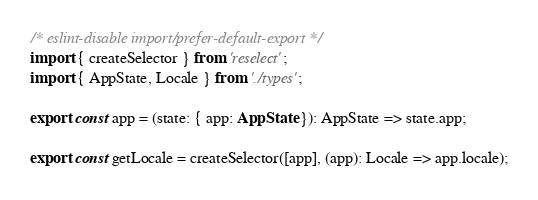<code> <loc_0><loc_0><loc_500><loc_500><_TypeScript_>/* eslint-disable import/prefer-default-export */
import { createSelector } from 'reselect';
import { AppState, Locale } from './types';

export const app = (state: { app: AppState }): AppState => state.app;

export const getLocale = createSelector([app], (app): Locale => app.locale);
</code> 